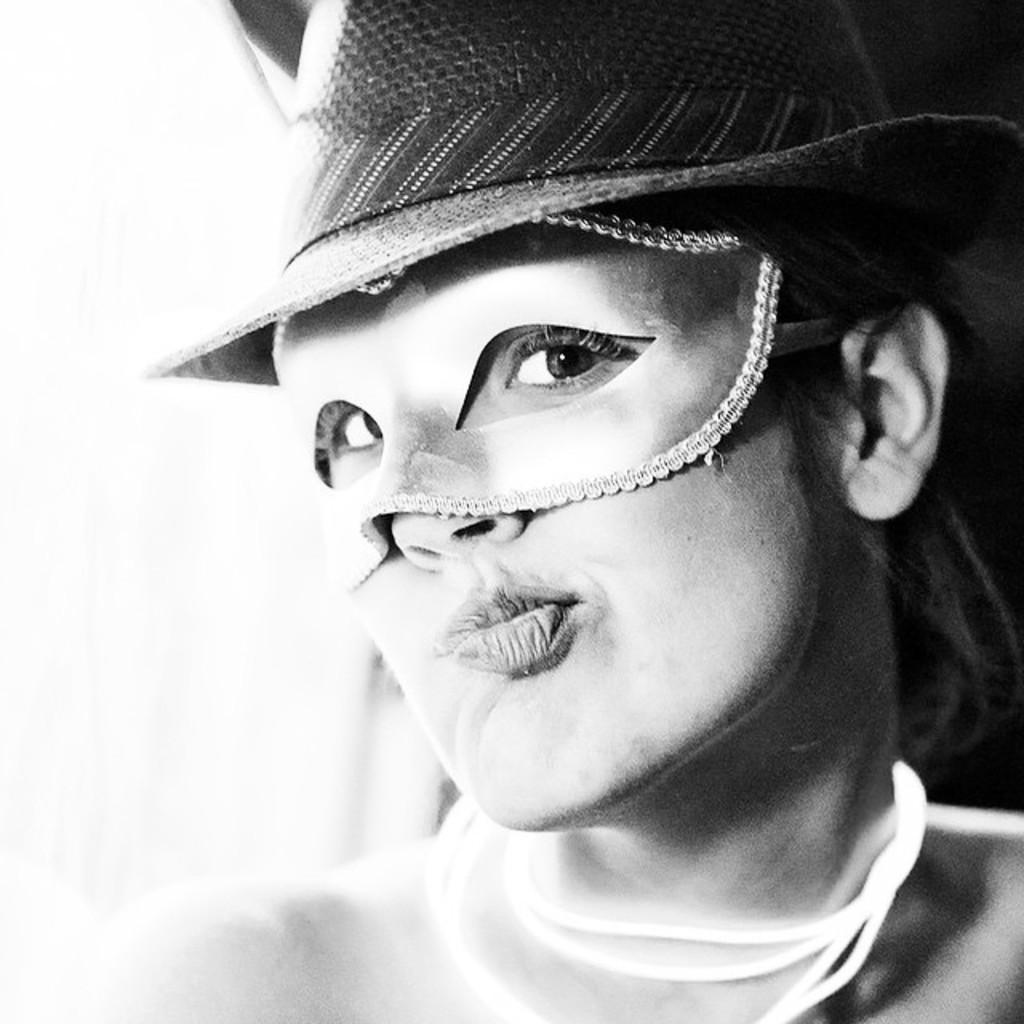What is the color scheme of the image? The image is black and white. Who is present in the image? There is a woman in the image. What is the woman wearing to cover her eyes? The woman is wearing a mask covering her eyes. What type of headwear is the woman wearing? The woman is wearing a hat on her head. What type of silk material is used to make the woman's hat in the image? There is no mention of silk or any specific material used for the hat in the image. 